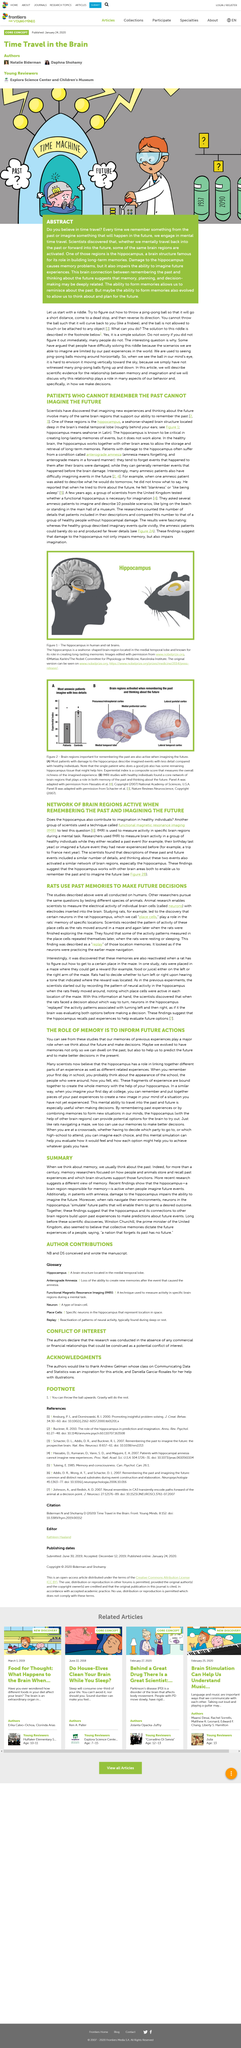Mention a couple of crucial points in this snapshot. For over a century, memory researchers have dedicated their efforts to understanding how people and animals store and recall past experiences, with a particular focus on the brain structures that support these functions. Neurons are primarily located in the brain, specifically in the cerebral cortex and brainstem regions. Winston Churchill was the prime minister of the United Kingdom. Memory is typically associated with the past and recollections of past events and experiences. The shape of the hippocampus is seahorse-shaped. 